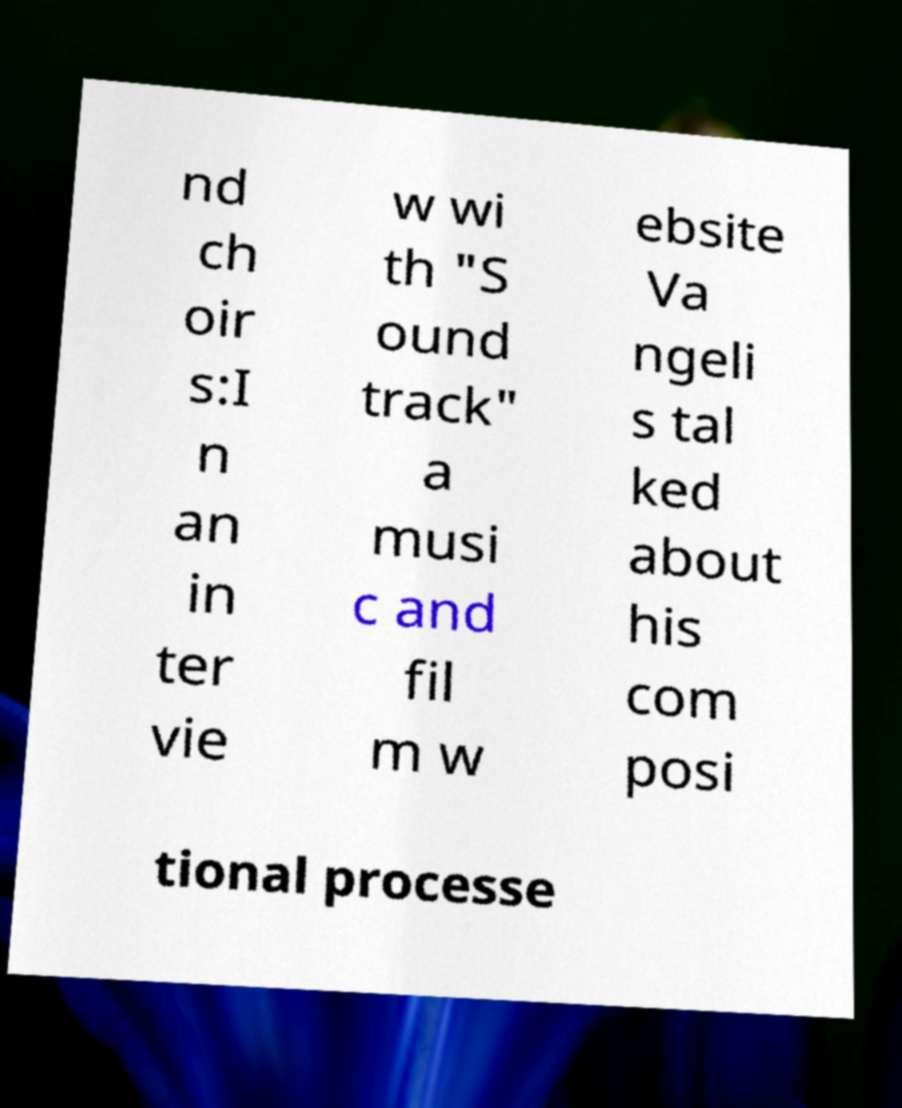Could you extract and type out the text from this image? nd ch oir s:I n an in ter vie w wi th "S ound track" a musi c and fil m w ebsite Va ngeli s tal ked about his com posi tional processe 